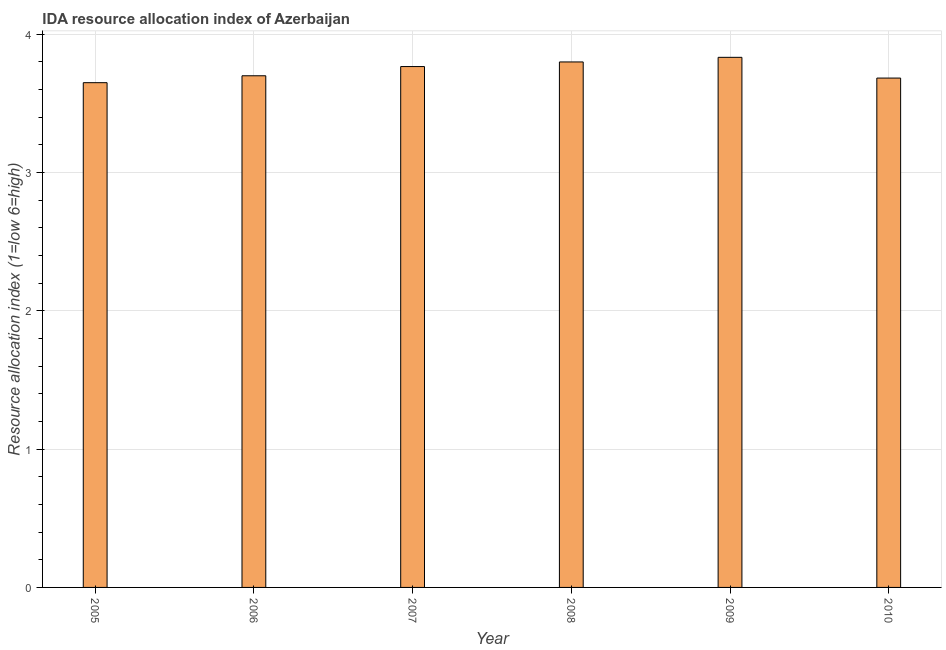Does the graph contain any zero values?
Provide a short and direct response. No. What is the title of the graph?
Your answer should be compact. IDA resource allocation index of Azerbaijan. What is the label or title of the X-axis?
Offer a terse response. Year. What is the label or title of the Y-axis?
Keep it short and to the point. Resource allocation index (1=low 6=high). Across all years, what is the maximum ida resource allocation index?
Your answer should be very brief. 3.83. Across all years, what is the minimum ida resource allocation index?
Make the answer very short. 3.65. In which year was the ida resource allocation index minimum?
Your response must be concise. 2005. What is the sum of the ida resource allocation index?
Your answer should be very brief. 22.43. What is the difference between the ida resource allocation index in 2007 and 2009?
Keep it short and to the point. -0.07. What is the average ida resource allocation index per year?
Ensure brevity in your answer.  3.74. What is the median ida resource allocation index?
Keep it short and to the point. 3.73. In how many years, is the ida resource allocation index greater than 0.8 ?
Provide a succinct answer. 6. What is the ratio of the ida resource allocation index in 2008 to that in 2010?
Your answer should be very brief. 1.03. What is the difference between the highest and the second highest ida resource allocation index?
Your response must be concise. 0.03. Is the sum of the ida resource allocation index in 2009 and 2010 greater than the maximum ida resource allocation index across all years?
Your response must be concise. Yes. What is the difference between the highest and the lowest ida resource allocation index?
Your response must be concise. 0.18. What is the Resource allocation index (1=low 6=high) of 2005?
Your answer should be very brief. 3.65. What is the Resource allocation index (1=low 6=high) in 2007?
Keep it short and to the point. 3.77. What is the Resource allocation index (1=low 6=high) in 2008?
Provide a succinct answer. 3.8. What is the Resource allocation index (1=low 6=high) in 2009?
Your response must be concise. 3.83. What is the Resource allocation index (1=low 6=high) of 2010?
Your response must be concise. 3.68. What is the difference between the Resource allocation index (1=low 6=high) in 2005 and 2006?
Make the answer very short. -0.05. What is the difference between the Resource allocation index (1=low 6=high) in 2005 and 2007?
Your response must be concise. -0.12. What is the difference between the Resource allocation index (1=low 6=high) in 2005 and 2008?
Provide a succinct answer. -0.15. What is the difference between the Resource allocation index (1=low 6=high) in 2005 and 2009?
Ensure brevity in your answer.  -0.18. What is the difference between the Resource allocation index (1=low 6=high) in 2005 and 2010?
Give a very brief answer. -0.03. What is the difference between the Resource allocation index (1=low 6=high) in 2006 and 2007?
Ensure brevity in your answer.  -0.07. What is the difference between the Resource allocation index (1=low 6=high) in 2006 and 2009?
Your answer should be very brief. -0.13. What is the difference between the Resource allocation index (1=low 6=high) in 2006 and 2010?
Your response must be concise. 0.02. What is the difference between the Resource allocation index (1=low 6=high) in 2007 and 2008?
Provide a succinct answer. -0.03. What is the difference between the Resource allocation index (1=low 6=high) in 2007 and 2009?
Provide a short and direct response. -0.07. What is the difference between the Resource allocation index (1=low 6=high) in 2007 and 2010?
Provide a succinct answer. 0.08. What is the difference between the Resource allocation index (1=low 6=high) in 2008 and 2009?
Ensure brevity in your answer.  -0.03. What is the difference between the Resource allocation index (1=low 6=high) in 2008 and 2010?
Give a very brief answer. 0.12. What is the difference between the Resource allocation index (1=low 6=high) in 2009 and 2010?
Give a very brief answer. 0.15. What is the ratio of the Resource allocation index (1=low 6=high) in 2005 to that in 2006?
Keep it short and to the point. 0.99. What is the ratio of the Resource allocation index (1=low 6=high) in 2005 to that in 2007?
Your answer should be very brief. 0.97. What is the ratio of the Resource allocation index (1=low 6=high) in 2005 to that in 2008?
Make the answer very short. 0.96. What is the ratio of the Resource allocation index (1=low 6=high) in 2005 to that in 2009?
Provide a short and direct response. 0.95. What is the ratio of the Resource allocation index (1=low 6=high) in 2006 to that in 2007?
Your answer should be very brief. 0.98. What is the ratio of the Resource allocation index (1=low 6=high) in 2007 to that in 2008?
Ensure brevity in your answer.  0.99. What is the ratio of the Resource allocation index (1=low 6=high) in 2008 to that in 2009?
Keep it short and to the point. 0.99. What is the ratio of the Resource allocation index (1=low 6=high) in 2008 to that in 2010?
Offer a very short reply. 1.03. What is the ratio of the Resource allocation index (1=low 6=high) in 2009 to that in 2010?
Ensure brevity in your answer.  1.04. 